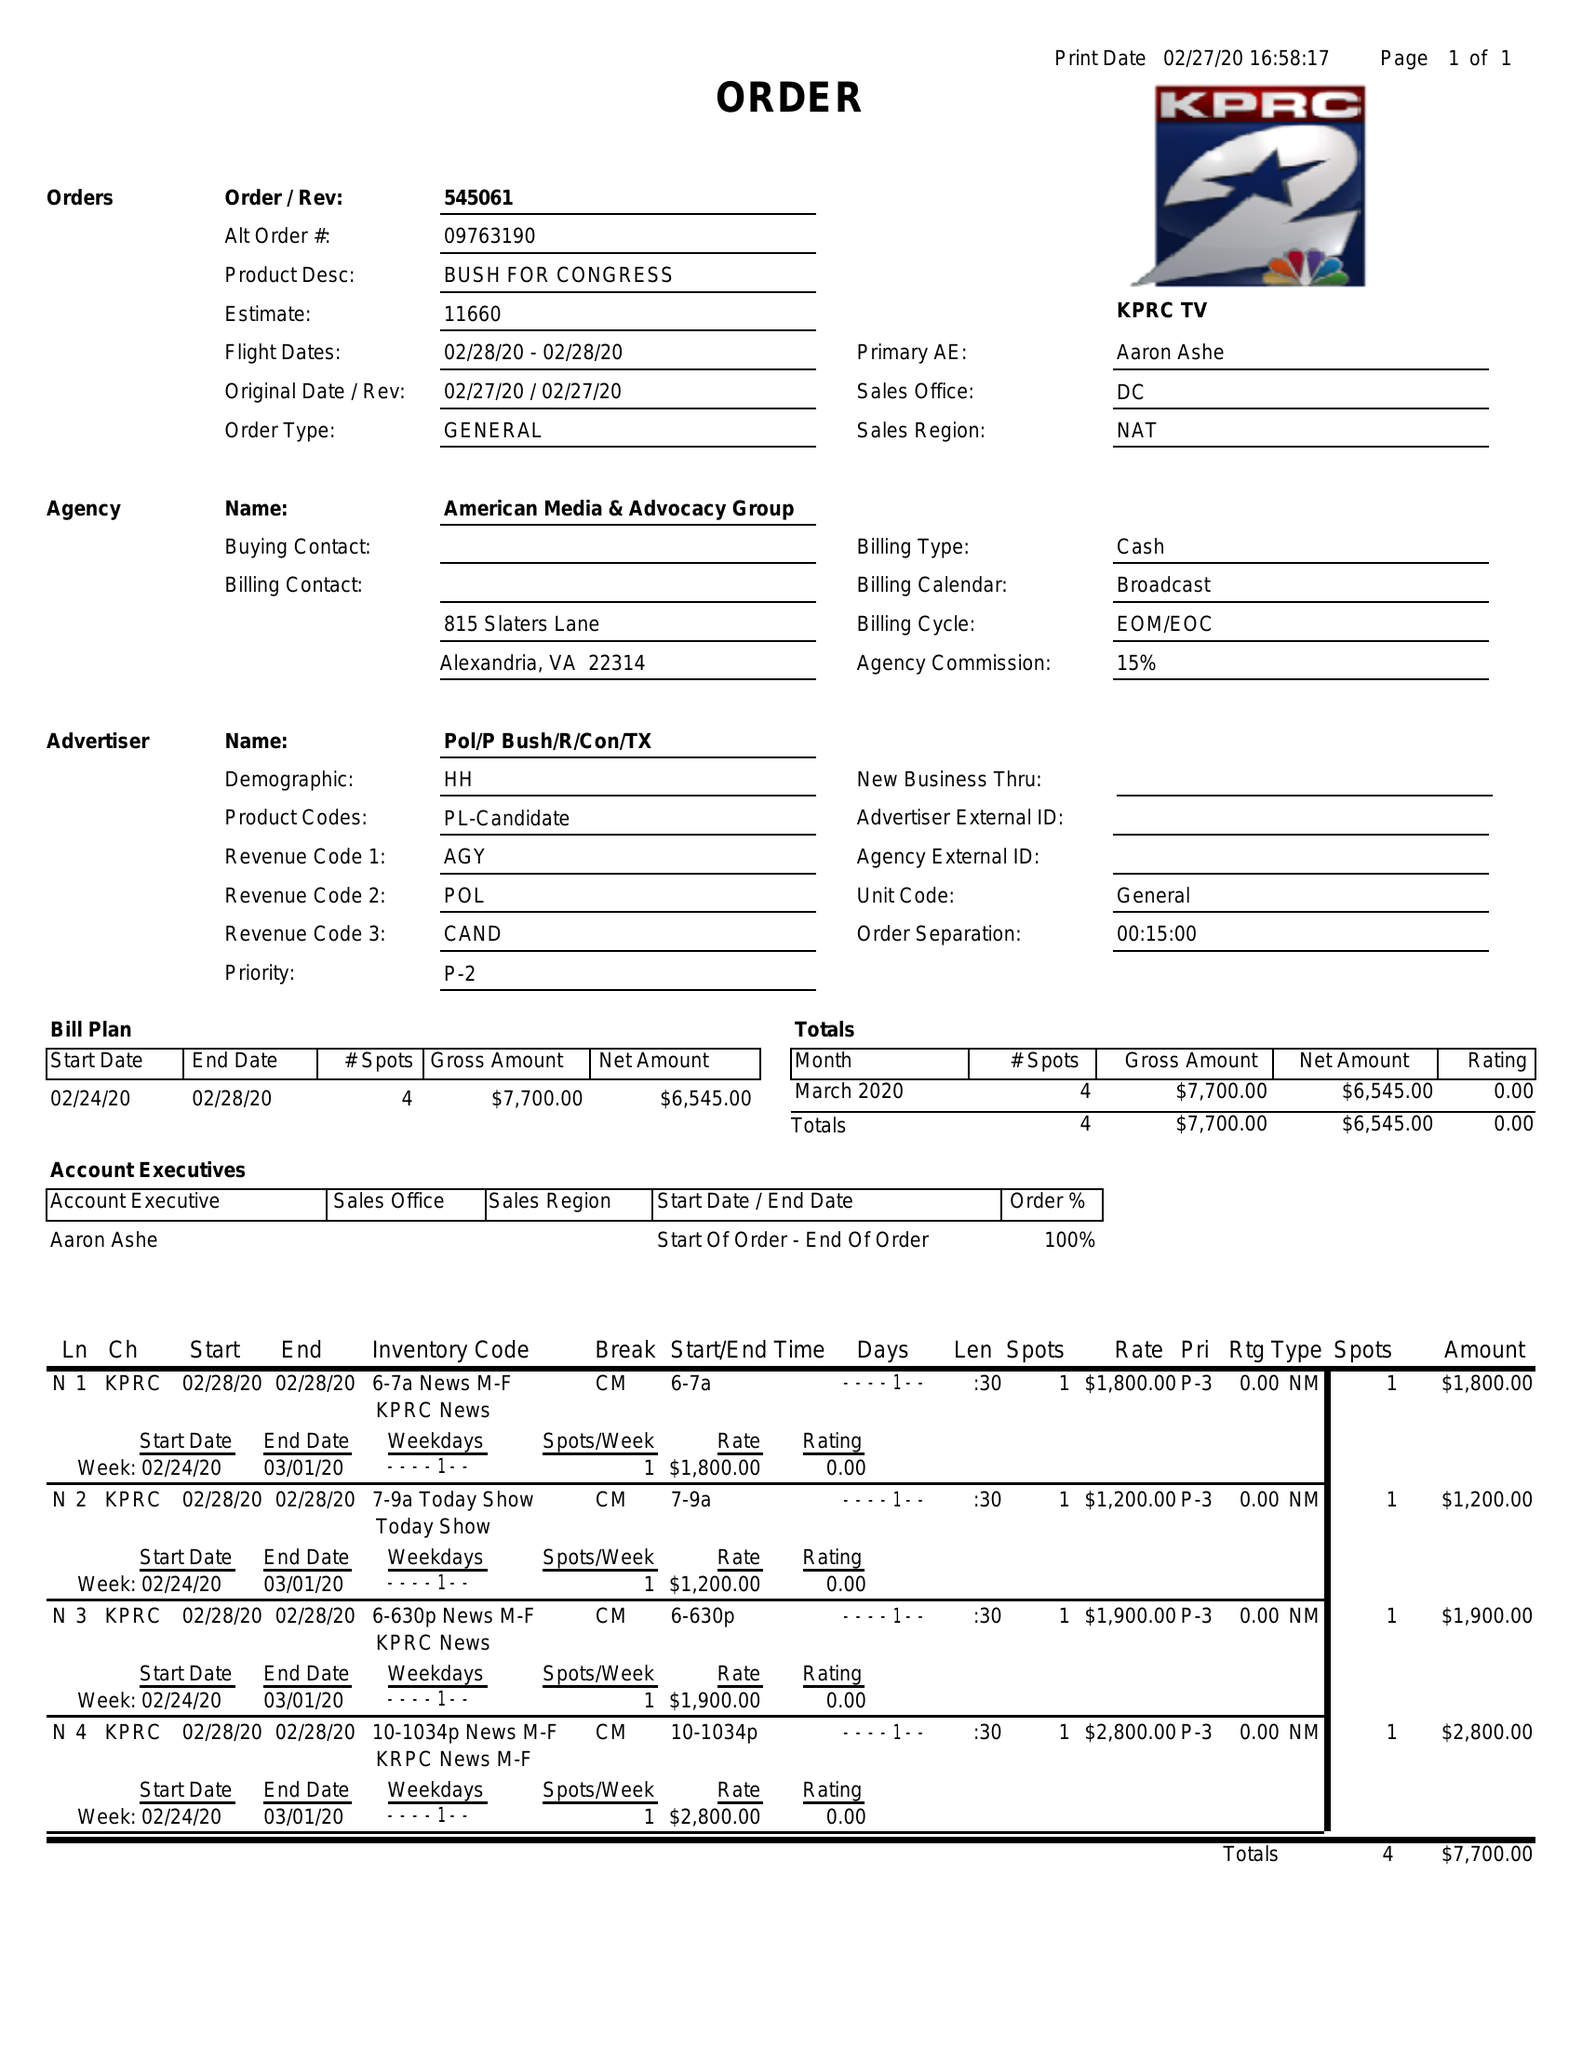What is the value for the flight_from?
Answer the question using a single word or phrase. 02/28/20 